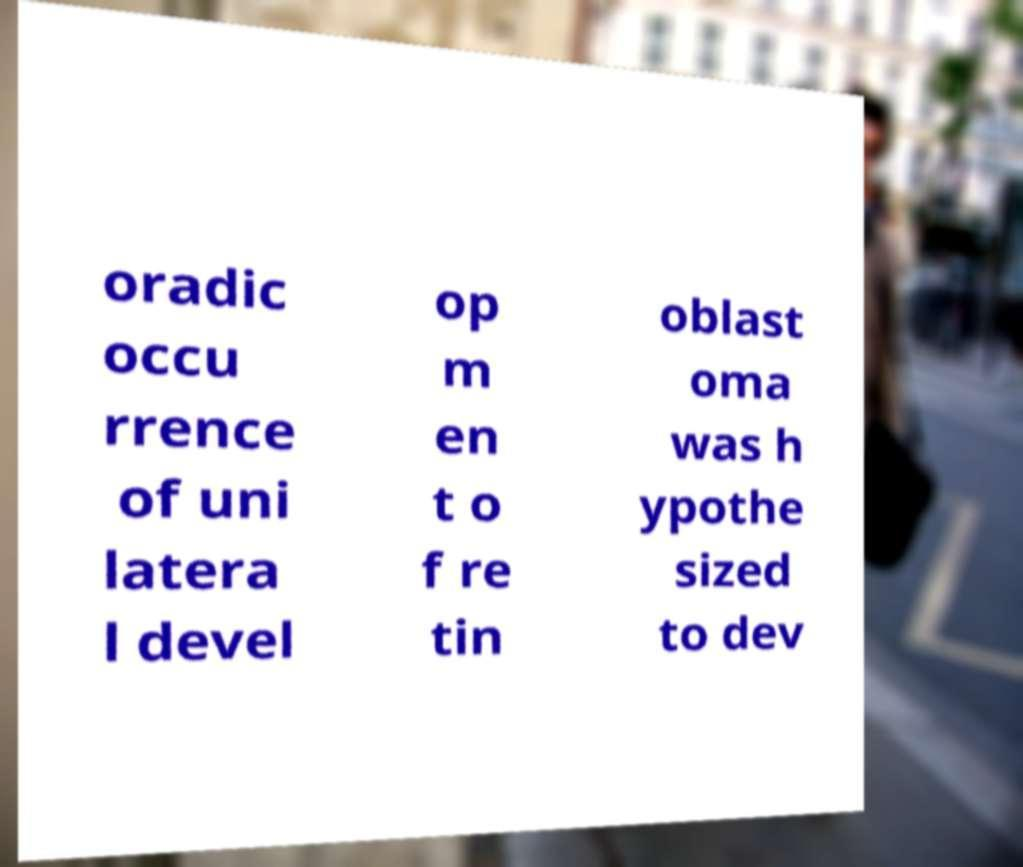Please identify and transcribe the text found in this image. oradic occu rrence of uni latera l devel op m en t o f re tin oblast oma was h ypothe sized to dev 